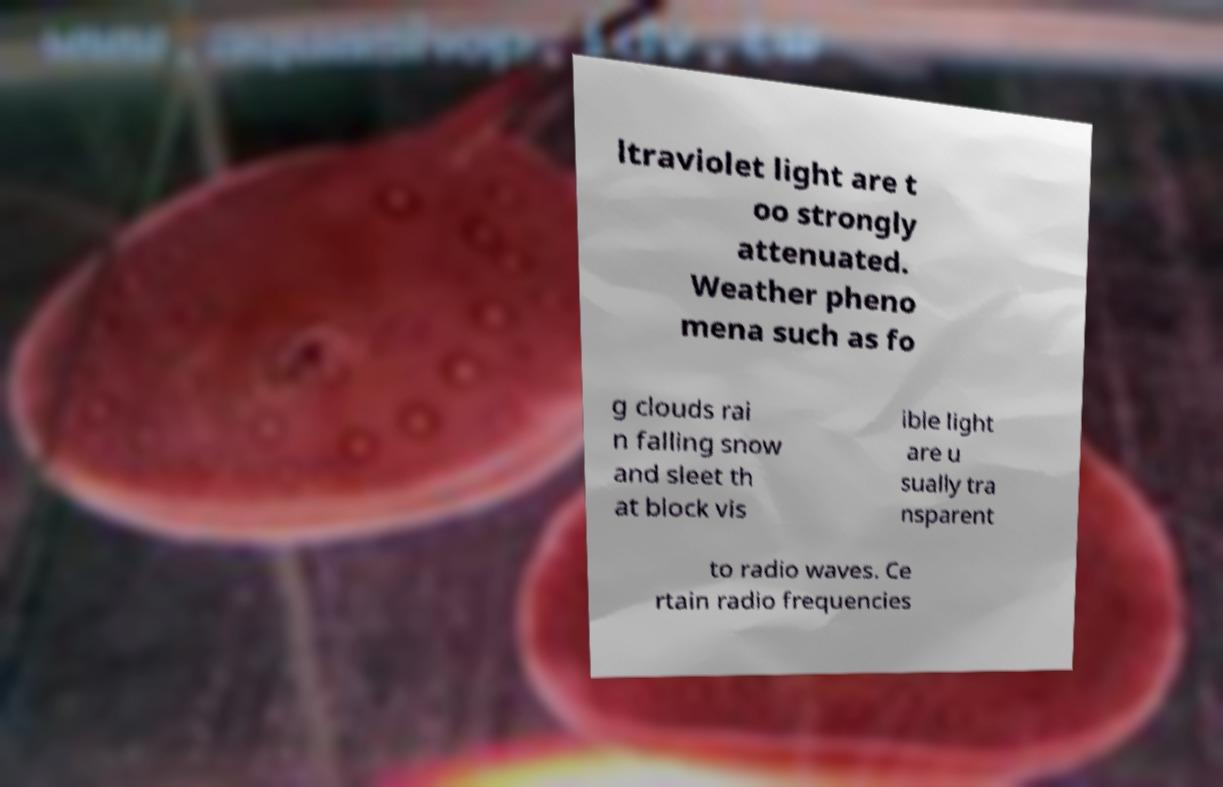Can you accurately transcribe the text from the provided image for me? ltraviolet light are t oo strongly attenuated. Weather pheno mena such as fo g clouds rai n falling snow and sleet th at block vis ible light are u sually tra nsparent to radio waves. Ce rtain radio frequencies 